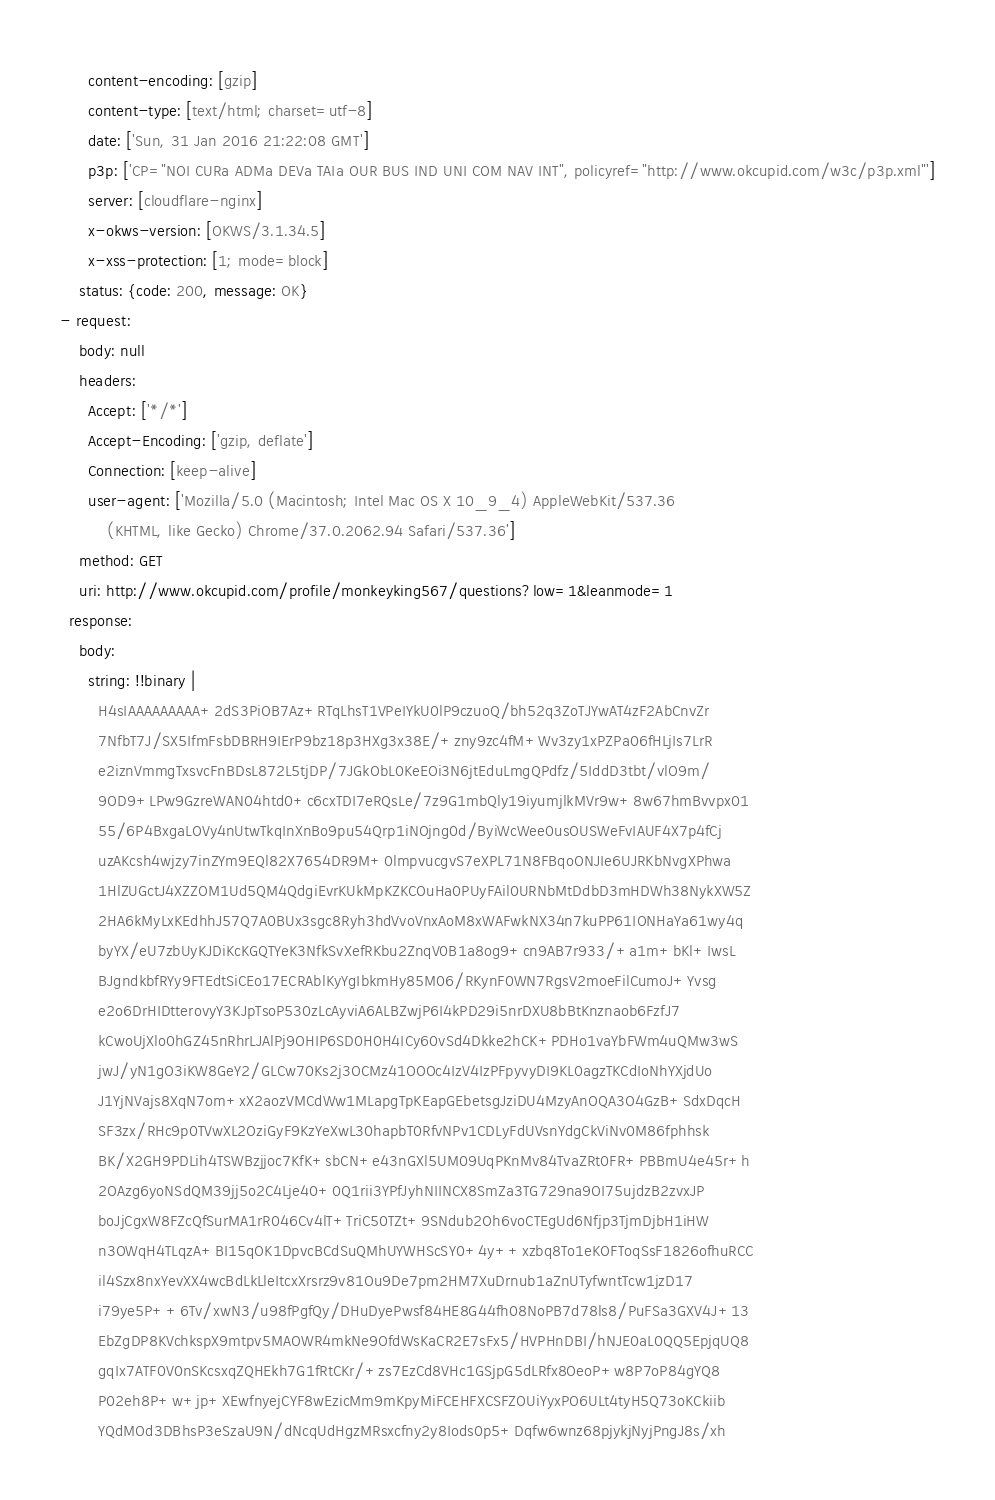<code> <loc_0><loc_0><loc_500><loc_500><_YAML_>      content-encoding: [gzip]
      content-type: [text/html; charset=utf-8]
      date: ['Sun, 31 Jan 2016 21:22:08 GMT']
      p3p: ['CP="NOI CURa ADMa DEVa TAIa OUR BUS IND UNI COM NAV INT", policyref="http://www.okcupid.com/w3c/p3p.xml"']
      server: [cloudflare-nginx]
      x-okws-version: [OKWS/3.1.34.5]
      x-xss-protection: [1; mode=block]
    status: {code: 200, message: OK}
- request:
    body: null
    headers:
      Accept: ['*/*']
      Accept-Encoding: ['gzip, deflate']
      Connection: [keep-alive]
      user-agent: ['Mozilla/5.0 (Macintosh; Intel Mac OS X 10_9_4) AppleWebKit/537.36
          (KHTML, like Gecko) Chrome/37.0.2062.94 Safari/537.36']
    method: GET
    uri: http://www.okcupid.com/profile/monkeyking567/questions?low=1&leanmode=1
  response:
    body:
      string: !!binary |
        H4sIAAAAAAAAA+2dS3PiOB7Az+RTqLhsT1VPeIYkU0lP9czuoQ/bh52q3ZoTJYwAT4zF2AbCnvZr
        7NfbT7J/SX5IfmFsbDBRH9IErP9bz18p3HXg3x38E/+zny9zc4fM+Wv3zy1xPZPa06fHLjIs7LrR
        e2iznVmmgTxsvcFnBDsL872L5tjDP/7JGkObL0KeEOi3N6jtEduLmgQPdfz/5IddD3tbt/vlO9m/
        9OD9+LPw9GzreWAN04htd0+c6cxTDI7eRQsLe/7z9G1mbQly19iyumjlkMVr9w+8w67hmBvvpx01
        55/6P4BxgaLOVy4nUtwTkqInXnBo9pu54Qrp1iNOjng0d/ByiWcWee0usOUSWeFvIAUF4X7p4fCj
        uzAKcsh4wjzy7inZYm9EQl82X7654DR9M+0lmpvucgvS7eXPL71N8FBqoONJIe6UJRKbNvgXPhwa
        1HlZUGctJ4XZZOM1Ud5QM4QdgiEvrKUkMpKZKCOuHa0PUyFAil0URNbMtDdbD3mHDWh38NykXW5Z
        2HA6kMyLxKEdhhJ57Q7A0BUx3sgc8Ryh3hdVvoVnxAoM8xWAFwkNX34n7kuPP61IONHaYa61wy4q
        byYX/eU7zbUyKJDiKcKGQTYeK3NfkSvXefRKbu2ZnqV0B1a8og9+cn9AB7r933/+a1m+bKl+IwsL
        BJgndkbfRYy9FTEdtSiCEo17ECRAblKyYgIbkmHy85M06/RKynF0WN7RgsV2moeFilCumoJ+Yvsg
        e2o6DrHIDtterovyY3KJpTsoP530zLcAyviA6ALBZwjP6I4kPD29i5nrDXU8bBtKnznaob6FzfJ7
        kCwoUjXlo0hGZ45nRhrLJAlPj9OHIP6SD0H0H4ICy60vSd4Dkke2hCK+PDHo1vaYbFWm4uQMw3wS
        jwJ/yN1gO3iKW8GeY2/GLCw70Ks2j3OCMz41OOOc4IzV4IzPFpyvyDI9KL0agzTKCdIoNhYXjdUo
        J1YjNVajs8XqN7om+xX2aozVMCdWw1MLapgTpKEapGEbetsgJziDU4MzyAnOQA3O4GzB+SdxDqcH
        SF3zx/RHc9p0TVwXL2OziGyF9KzYeXwL30hapbT0RfvNPv1CDLyFdUVsnYdgCkViNv0M86fphhsk
        BK/X2GH9PDLih4TSWBzjjoc7KfK+sbCN+e43nGXl5UM09UqPKnMv84TvaZRt0FR+PBBmU4e45r+h
        2OAzg6yoNSdQM39jj5o2C4Lje40+0Q1rii3YPfJyhNIINCX8SmZa3TG729na9OI75ujdzB2zvxJP
        boJjCgxW8FZcQfSurMA1rR046Cv4lT+TriC50TZt+9SNdub2Oh6voCTEgUd6Nfjp3TjmDjbH1iHW
        n3OWqH4TLqzA+BI15qOK1DpvcBCdSuQMhUYWHScSY0+4y++xzbq8To1eKOFToqSsF1826ofhuRCC
        il4Szx8nxYevXX4wcBdLkLleItcxXrsrz9v81Ou9De7pm2HM7XuDrnub1aZnUTyfwntTcw1jzD17
        i79ye5P++6Tv/xwN3/u98fPgfQy/DHuDyePwsf84HE8G44fh08NoPB7d78ls8/PuFSa3GXV4J+13
        EbZgDP8KVchkspX9mtpv5MAOWR4mkNe9OfdWsKaCR2E7sFx5/HVPHnDBI/hNJE0aL0QQ5EpjqUQ8
        gqIx7ATF0V0nSKcsxqZQHEkh7G1fRtCKr/+zs7EzCd8VHc1GSjpG5dLRfx8OeoP+w8P7oP84gYQ8
        P02eh8P+w+jp+XEwfnyejCYF8wEzicMm9mKpyMiFCEHFXCSFZOUiYyxPO6ULt4tyH5Q73oKCkiib
        YQdMOd3DBhsP3eSzaU9N/dNcqUdHgzMRsxcfny2y8Iods0p5+Dqfw6wnz68pjykjNyjPngJ8s/xh</code> 